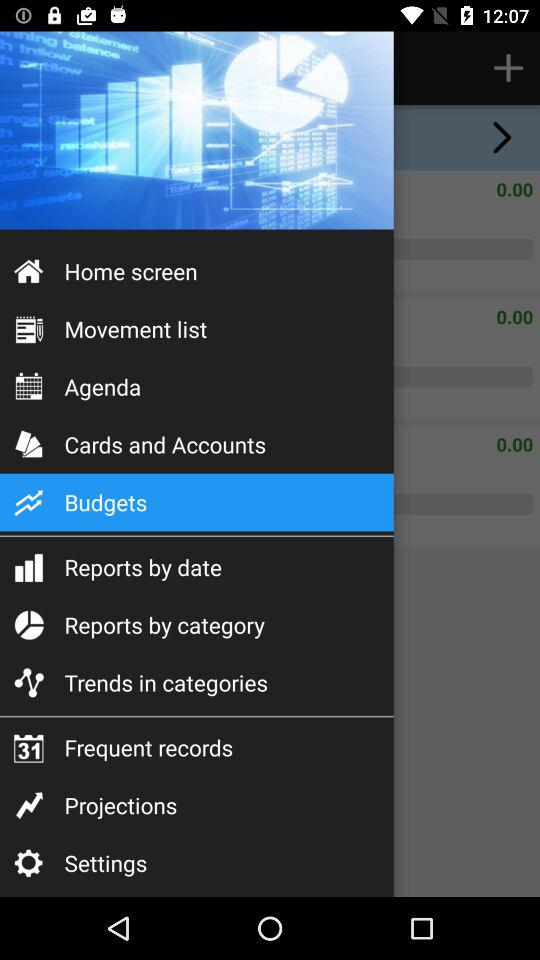How many notifications are there in "Settings"?
When the provided information is insufficient, respond with <no answer>. <no answer> 